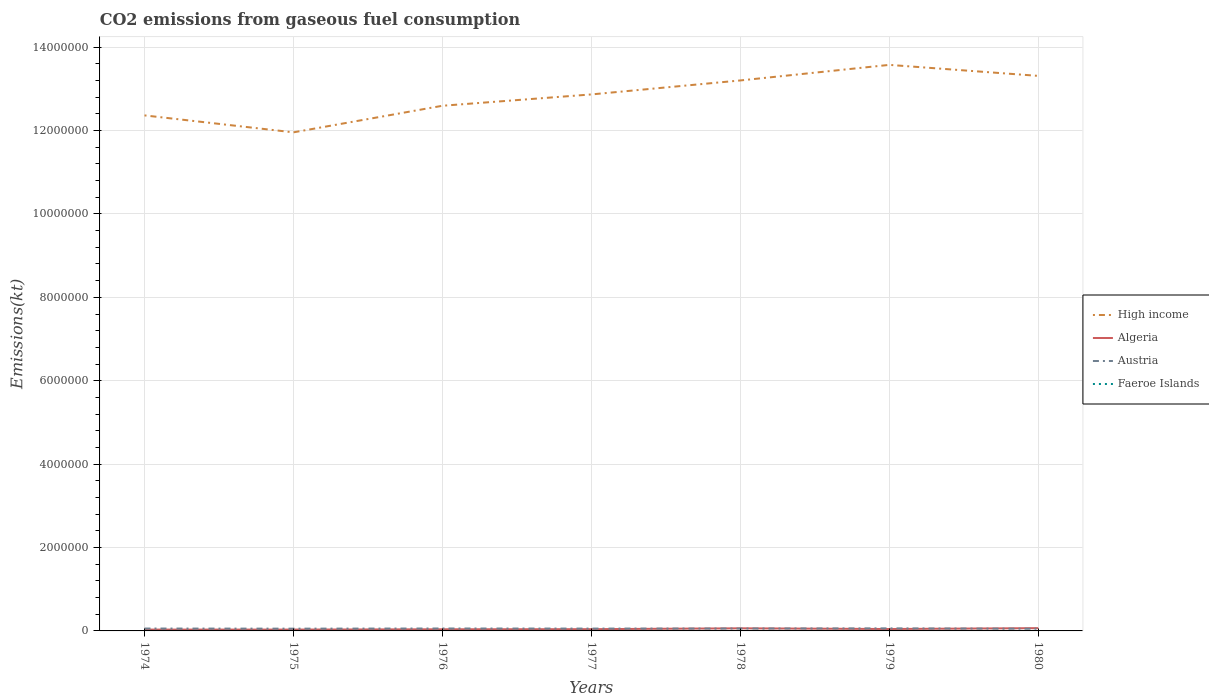Is the number of lines equal to the number of legend labels?
Give a very brief answer. Yes. Across all years, what is the maximum amount of CO2 emitted in Faeroe Islands?
Make the answer very short. 300.69. In which year was the amount of CO2 emitted in High income maximum?
Provide a short and direct response. 1975. What is the total amount of CO2 emitted in High income in the graph?
Keep it short and to the point. -3.73e+05. What is the difference between the highest and the second highest amount of CO2 emitted in High income?
Ensure brevity in your answer.  1.62e+06. Is the amount of CO2 emitted in Algeria strictly greater than the amount of CO2 emitted in Austria over the years?
Make the answer very short. No. What is the difference between two consecutive major ticks on the Y-axis?
Ensure brevity in your answer.  2.00e+06. Does the graph contain any zero values?
Make the answer very short. No. Does the graph contain grids?
Your answer should be very brief. Yes. How are the legend labels stacked?
Offer a very short reply. Vertical. What is the title of the graph?
Provide a short and direct response. CO2 emissions from gaseous fuel consumption. Does "Egypt, Arab Rep." appear as one of the legend labels in the graph?
Make the answer very short. No. What is the label or title of the Y-axis?
Your answer should be compact. Emissions(kt). What is the Emissions(kt) in High income in 1974?
Offer a very short reply. 1.24e+07. What is the Emissions(kt) in Algeria in 1974?
Offer a terse response. 3.19e+04. What is the Emissions(kt) in Austria in 1974?
Your answer should be very brief. 5.75e+04. What is the Emissions(kt) in Faeroe Islands in 1974?
Ensure brevity in your answer.  300.69. What is the Emissions(kt) of High income in 1975?
Offer a very short reply. 1.20e+07. What is the Emissions(kt) in Algeria in 1975?
Provide a succinct answer. 3.20e+04. What is the Emissions(kt) of Austria in 1975?
Provide a short and direct response. 5.44e+04. What is the Emissions(kt) in Faeroe Islands in 1975?
Keep it short and to the point. 348.37. What is the Emissions(kt) of High income in 1976?
Keep it short and to the point. 1.26e+07. What is the Emissions(kt) of Algeria in 1976?
Offer a very short reply. 3.92e+04. What is the Emissions(kt) in Austria in 1976?
Your answer should be very brief. 5.84e+04. What is the Emissions(kt) in Faeroe Islands in 1976?
Offer a terse response. 330.03. What is the Emissions(kt) of High income in 1977?
Offer a terse response. 1.29e+07. What is the Emissions(kt) of Algeria in 1977?
Keep it short and to the point. 4.19e+04. What is the Emissions(kt) of Austria in 1977?
Make the answer very short. 5.62e+04. What is the Emissions(kt) of Faeroe Islands in 1977?
Your answer should be compact. 407.04. What is the Emissions(kt) of High income in 1978?
Ensure brevity in your answer.  1.32e+07. What is the Emissions(kt) in Algeria in 1978?
Make the answer very short. 6.25e+04. What is the Emissions(kt) of Austria in 1978?
Provide a succinct answer. 5.75e+04. What is the Emissions(kt) in Faeroe Islands in 1978?
Offer a very short reply. 399.7. What is the Emissions(kt) of High income in 1979?
Provide a succinct answer. 1.36e+07. What is the Emissions(kt) in Algeria in 1979?
Offer a terse response. 4.56e+04. What is the Emissions(kt) in Austria in 1979?
Offer a very short reply. 6.16e+04. What is the Emissions(kt) of Faeroe Islands in 1979?
Make the answer very short. 480.38. What is the Emissions(kt) of High income in 1980?
Ensure brevity in your answer.  1.33e+07. What is the Emissions(kt) of Algeria in 1980?
Your response must be concise. 6.65e+04. What is the Emissions(kt) in Austria in 1980?
Offer a very short reply. 5.23e+04. What is the Emissions(kt) in Faeroe Islands in 1980?
Your answer should be very brief. 421.7. Across all years, what is the maximum Emissions(kt) in High income?
Ensure brevity in your answer.  1.36e+07. Across all years, what is the maximum Emissions(kt) of Algeria?
Provide a succinct answer. 6.65e+04. Across all years, what is the maximum Emissions(kt) in Austria?
Your answer should be compact. 6.16e+04. Across all years, what is the maximum Emissions(kt) in Faeroe Islands?
Your answer should be very brief. 480.38. Across all years, what is the minimum Emissions(kt) in High income?
Your response must be concise. 1.20e+07. Across all years, what is the minimum Emissions(kt) in Algeria?
Your answer should be compact. 3.19e+04. Across all years, what is the minimum Emissions(kt) of Austria?
Offer a very short reply. 5.23e+04. Across all years, what is the minimum Emissions(kt) in Faeroe Islands?
Provide a succinct answer. 300.69. What is the total Emissions(kt) in High income in the graph?
Offer a terse response. 8.99e+07. What is the total Emissions(kt) in Algeria in the graph?
Your answer should be compact. 3.20e+05. What is the total Emissions(kt) in Austria in the graph?
Make the answer very short. 3.98e+05. What is the total Emissions(kt) in Faeroe Islands in the graph?
Provide a short and direct response. 2687.91. What is the difference between the Emissions(kt) in High income in 1974 and that in 1975?
Ensure brevity in your answer.  4.07e+05. What is the difference between the Emissions(kt) in Algeria in 1974 and that in 1975?
Keep it short and to the point. -124.68. What is the difference between the Emissions(kt) of Austria in 1974 and that in 1975?
Ensure brevity in your answer.  3076.61. What is the difference between the Emissions(kt) in Faeroe Islands in 1974 and that in 1975?
Provide a short and direct response. -47.67. What is the difference between the Emissions(kt) of High income in 1974 and that in 1976?
Provide a succinct answer. -2.31e+05. What is the difference between the Emissions(kt) of Algeria in 1974 and that in 1976?
Your answer should be compact. -7264.33. What is the difference between the Emissions(kt) in Austria in 1974 and that in 1976?
Offer a terse response. -946.09. What is the difference between the Emissions(kt) of Faeroe Islands in 1974 and that in 1976?
Offer a very short reply. -29.34. What is the difference between the Emissions(kt) of High income in 1974 and that in 1977?
Ensure brevity in your answer.  -5.03e+05. What is the difference between the Emissions(kt) of Algeria in 1974 and that in 1977?
Offer a terse response. -9985.24. What is the difference between the Emissions(kt) of Austria in 1974 and that in 1977?
Provide a short and direct response. 1250.45. What is the difference between the Emissions(kt) in Faeroe Islands in 1974 and that in 1977?
Provide a short and direct response. -106.34. What is the difference between the Emissions(kt) in High income in 1974 and that in 1978?
Make the answer very short. -8.38e+05. What is the difference between the Emissions(kt) of Algeria in 1974 and that in 1978?
Provide a succinct answer. -3.06e+04. What is the difference between the Emissions(kt) in Austria in 1974 and that in 1978?
Offer a very short reply. -14.67. What is the difference between the Emissions(kt) in Faeroe Islands in 1974 and that in 1978?
Keep it short and to the point. -99.01. What is the difference between the Emissions(kt) of High income in 1974 and that in 1979?
Your answer should be very brief. -1.21e+06. What is the difference between the Emissions(kt) in Algeria in 1974 and that in 1979?
Offer a very short reply. -1.37e+04. What is the difference between the Emissions(kt) of Austria in 1974 and that in 1979?
Offer a terse response. -4125.38. What is the difference between the Emissions(kt) in Faeroe Islands in 1974 and that in 1979?
Your answer should be very brief. -179.68. What is the difference between the Emissions(kt) of High income in 1974 and that in 1980?
Your response must be concise. -9.48e+05. What is the difference between the Emissions(kt) of Algeria in 1974 and that in 1980?
Provide a short and direct response. -3.46e+04. What is the difference between the Emissions(kt) in Austria in 1974 and that in 1980?
Provide a short and direct response. 5163.14. What is the difference between the Emissions(kt) in Faeroe Islands in 1974 and that in 1980?
Keep it short and to the point. -121.01. What is the difference between the Emissions(kt) in High income in 1975 and that in 1976?
Your answer should be very brief. -6.37e+05. What is the difference between the Emissions(kt) of Algeria in 1975 and that in 1976?
Provide a succinct answer. -7139.65. What is the difference between the Emissions(kt) of Austria in 1975 and that in 1976?
Offer a terse response. -4022.7. What is the difference between the Emissions(kt) in Faeroe Islands in 1975 and that in 1976?
Provide a short and direct response. 18.34. What is the difference between the Emissions(kt) in High income in 1975 and that in 1977?
Your answer should be compact. -9.09e+05. What is the difference between the Emissions(kt) of Algeria in 1975 and that in 1977?
Ensure brevity in your answer.  -9860.56. What is the difference between the Emissions(kt) in Austria in 1975 and that in 1977?
Provide a succinct answer. -1826.17. What is the difference between the Emissions(kt) in Faeroe Islands in 1975 and that in 1977?
Your answer should be compact. -58.67. What is the difference between the Emissions(kt) of High income in 1975 and that in 1978?
Your answer should be very brief. -1.24e+06. What is the difference between the Emissions(kt) of Algeria in 1975 and that in 1978?
Your answer should be very brief. -3.05e+04. What is the difference between the Emissions(kt) of Austria in 1975 and that in 1978?
Your answer should be very brief. -3091.28. What is the difference between the Emissions(kt) of Faeroe Islands in 1975 and that in 1978?
Your response must be concise. -51.34. What is the difference between the Emissions(kt) of High income in 1975 and that in 1979?
Make the answer very short. -1.62e+06. What is the difference between the Emissions(kt) of Algeria in 1975 and that in 1979?
Offer a terse response. -1.36e+04. What is the difference between the Emissions(kt) of Austria in 1975 and that in 1979?
Offer a very short reply. -7201.99. What is the difference between the Emissions(kt) in Faeroe Islands in 1975 and that in 1979?
Offer a very short reply. -132.01. What is the difference between the Emissions(kt) in High income in 1975 and that in 1980?
Provide a short and direct response. -1.35e+06. What is the difference between the Emissions(kt) in Algeria in 1975 and that in 1980?
Provide a succinct answer. -3.45e+04. What is the difference between the Emissions(kt) in Austria in 1975 and that in 1980?
Offer a very short reply. 2086.52. What is the difference between the Emissions(kt) of Faeroe Islands in 1975 and that in 1980?
Provide a succinct answer. -73.34. What is the difference between the Emissions(kt) of High income in 1976 and that in 1977?
Make the answer very short. -2.72e+05. What is the difference between the Emissions(kt) in Algeria in 1976 and that in 1977?
Offer a very short reply. -2720.91. What is the difference between the Emissions(kt) in Austria in 1976 and that in 1977?
Keep it short and to the point. 2196.53. What is the difference between the Emissions(kt) of Faeroe Islands in 1976 and that in 1977?
Keep it short and to the point. -77.01. What is the difference between the Emissions(kt) in High income in 1976 and that in 1978?
Offer a terse response. -6.07e+05. What is the difference between the Emissions(kt) in Algeria in 1976 and that in 1978?
Your answer should be very brief. -2.34e+04. What is the difference between the Emissions(kt) in Austria in 1976 and that in 1978?
Your answer should be compact. 931.42. What is the difference between the Emissions(kt) of Faeroe Islands in 1976 and that in 1978?
Make the answer very short. -69.67. What is the difference between the Emissions(kt) of High income in 1976 and that in 1979?
Provide a succinct answer. -9.81e+05. What is the difference between the Emissions(kt) in Algeria in 1976 and that in 1979?
Provide a succinct answer. -6450.25. What is the difference between the Emissions(kt) of Austria in 1976 and that in 1979?
Your response must be concise. -3179.29. What is the difference between the Emissions(kt) in Faeroe Islands in 1976 and that in 1979?
Provide a short and direct response. -150.35. What is the difference between the Emissions(kt) of High income in 1976 and that in 1980?
Ensure brevity in your answer.  -7.17e+05. What is the difference between the Emissions(kt) of Algeria in 1976 and that in 1980?
Offer a terse response. -2.73e+04. What is the difference between the Emissions(kt) in Austria in 1976 and that in 1980?
Make the answer very short. 6109.22. What is the difference between the Emissions(kt) in Faeroe Islands in 1976 and that in 1980?
Offer a terse response. -91.67. What is the difference between the Emissions(kt) of High income in 1977 and that in 1978?
Give a very brief answer. -3.35e+05. What is the difference between the Emissions(kt) of Algeria in 1977 and that in 1978?
Provide a succinct answer. -2.06e+04. What is the difference between the Emissions(kt) of Austria in 1977 and that in 1978?
Ensure brevity in your answer.  -1265.12. What is the difference between the Emissions(kt) of Faeroe Islands in 1977 and that in 1978?
Make the answer very short. 7.33. What is the difference between the Emissions(kt) of High income in 1977 and that in 1979?
Provide a short and direct response. -7.09e+05. What is the difference between the Emissions(kt) in Algeria in 1977 and that in 1979?
Make the answer very short. -3729.34. What is the difference between the Emissions(kt) in Austria in 1977 and that in 1979?
Ensure brevity in your answer.  -5375.82. What is the difference between the Emissions(kt) of Faeroe Islands in 1977 and that in 1979?
Your answer should be compact. -73.34. What is the difference between the Emissions(kt) of High income in 1977 and that in 1980?
Ensure brevity in your answer.  -4.45e+05. What is the difference between the Emissions(kt) of Algeria in 1977 and that in 1980?
Ensure brevity in your answer.  -2.46e+04. What is the difference between the Emissions(kt) in Austria in 1977 and that in 1980?
Your response must be concise. 3912.69. What is the difference between the Emissions(kt) of Faeroe Islands in 1977 and that in 1980?
Keep it short and to the point. -14.67. What is the difference between the Emissions(kt) in High income in 1978 and that in 1979?
Give a very brief answer. -3.73e+05. What is the difference between the Emissions(kt) in Algeria in 1978 and that in 1979?
Offer a terse response. 1.69e+04. What is the difference between the Emissions(kt) of Austria in 1978 and that in 1979?
Give a very brief answer. -4110.71. What is the difference between the Emissions(kt) in Faeroe Islands in 1978 and that in 1979?
Your answer should be compact. -80.67. What is the difference between the Emissions(kt) of High income in 1978 and that in 1980?
Provide a succinct answer. -1.10e+05. What is the difference between the Emissions(kt) of Algeria in 1978 and that in 1980?
Make the answer very short. -3989.7. What is the difference between the Emissions(kt) in Austria in 1978 and that in 1980?
Provide a succinct answer. 5177.8. What is the difference between the Emissions(kt) in Faeroe Islands in 1978 and that in 1980?
Your answer should be compact. -22. What is the difference between the Emissions(kt) in High income in 1979 and that in 1980?
Provide a succinct answer. 2.64e+05. What is the difference between the Emissions(kt) of Algeria in 1979 and that in 1980?
Give a very brief answer. -2.09e+04. What is the difference between the Emissions(kt) in Austria in 1979 and that in 1980?
Your answer should be compact. 9288.51. What is the difference between the Emissions(kt) in Faeroe Islands in 1979 and that in 1980?
Your answer should be very brief. 58.67. What is the difference between the Emissions(kt) in High income in 1974 and the Emissions(kt) in Algeria in 1975?
Keep it short and to the point. 1.23e+07. What is the difference between the Emissions(kt) in High income in 1974 and the Emissions(kt) in Austria in 1975?
Your answer should be compact. 1.23e+07. What is the difference between the Emissions(kt) in High income in 1974 and the Emissions(kt) in Faeroe Islands in 1975?
Your response must be concise. 1.24e+07. What is the difference between the Emissions(kt) of Algeria in 1974 and the Emissions(kt) of Austria in 1975?
Your response must be concise. -2.25e+04. What is the difference between the Emissions(kt) in Algeria in 1974 and the Emissions(kt) in Faeroe Islands in 1975?
Provide a short and direct response. 3.16e+04. What is the difference between the Emissions(kt) of Austria in 1974 and the Emissions(kt) of Faeroe Islands in 1975?
Your response must be concise. 5.71e+04. What is the difference between the Emissions(kt) in High income in 1974 and the Emissions(kt) in Algeria in 1976?
Give a very brief answer. 1.23e+07. What is the difference between the Emissions(kt) in High income in 1974 and the Emissions(kt) in Austria in 1976?
Offer a very short reply. 1.23e+07. What is the difference between the Emissions(kt) of High income in 1974 and the Emissions(kt) of Faeroe Islands in 1976?
Make the answer very short. 1.24e+07. What is the difference between the Emissions(kt) in Algeria in 1974 and the Emissions(kt) in Austria in 1976?
Give a very brief answer. -2.65e+04. What is the difference between the Emissions(kt) of Algeria in 1974 and the Emissions(kt) of Faeroe Islands in 1976?
Your response must be concise. 3.16e+04. What is the difference between the Emissions(kt) of Austria in 1974 and the Emissions(kt) of Faeroe Islands in 1976?
Keep it short and to the point. 5.71e+04. What is the difference between the Emissions(kt) of High income in 1974 and the Emissions(kt) of Algeria in 1977?
Ensure brevity in your answer.  1.23e+07. What is the difference between the Emissions(kt) in High income in 1974 and the Emissions(kt) in Austria in 1977?
Offer a terse response. 1.23e+07. What is the difference between the Emissions(kt) in High income in 1974 and the Emissions(kt) in Faeroe Islands in 1977?
Make the answer very short. 1.24e+07. What is the difference between the Emissions(kt) in Algeria in 1974 and the Emissions(kt) in Austria in 1977?
Offer a terse response. -2.43e+04. What is the difference between the Emissions(kt) in Algeria in 1974 and the Emissions(kt) in Faeroe Islands in 1977?
Your answer should be very brief. 3.15e+04. What is the difference between the Emissions(kt) in Austria in 1974 and the Emissions(kt) in Faeroe Islands in 1977?
Your response must be concise. 5.71e+04. What is the difference between the Emissions(kt) in High income in 1974 and the Emissions(kt) in Algeria in 1978?
Give a very brief answer. 1.23e+07. What is the difference between the Emissions(kt) of High income in 1974 and the Emissions(kt) of Austria in 1978?
Your answer should be very brief. 1.23e+07. What is the difference between the Emissions(kt) in High income in 1974 and the Emissions(kt) in Faeroe Islands in 1978?
Give a very brief answer. 1.24e+07. What is the difference between the Emissions(kt) in Algeria in 1974 and the Emissions(kt) in Austria in 1978?
Ensure brevity in your answer.  -2.56e+04. What is the difference between the Emissions(kt) of Algeria in 1974 and the Emissions(kt) of Faeroe Islands in 1978?
Your answer should be very brief. 3.15e+04. What is the difference between the Emissions(kt) in Austria in 1974 and the Emissions(kt) in Faeroe Islands in 1978?
Provide a short and direct response. 5.71e+04. What is the difference between the Emissions(kt) of High income in 1974 and the Emissions(kt) of Algeria in 1979?
Give a very brief answer. 1.23e+07. What is the difference between the Emissions(kt) in High income in 1974 and the Emissions(kt) in Austria in 1979?
Your answer should be very brief. 1.23e+07. What is the difference between the Emissions(kt) in High income in 1974 and the Emissions(kt) in Faeroe Islands in 1979?
Your answer should be very brief. 1.24e+07. What is the difference between the Emissions(kt) in Algeria in 1974 and the Emissions(kt) in Austria in 1979?
Make the answer very short. -2.97e+04. What is the difference between the Emissions(kt) in Algeria in 1974 and the Emissions(kt) in Faeroe Islands in 1979?
Offer a very short reply. 3.14e+04. What is the difference between the Emissions(kt) of Austria in 1974 and the Emissions(kt) of Faeroe Islands in 1979?
Give a very brief answer. 5.70e+04. What is the difference between the Emissions(kt) of High income in 1974 and the Emissions(kt) of Algeria in 1980?
Make the answer very short. 1.23e+07. What is the difference between the Emissions(kt) in High income in 1974 and the Emissions(kt) in Austria in 1980?
Offer a terse response. 1.23e+07. What is the difference between the Emissions(kt) in High income in 1974 and the Emissions(kt) in Faeroe Islands in 1980?
Your response must be concise. 1.24e+07. What is the difference between the Emissions(kt) in Algeria in 1974 and the Emissions(kt) in Austria in 1980?
Your answer should be very brief. -2.04e+04. What is the difference between the Emissions(kt) of Algeria in 1974 and the Emissions(kt) of Faeroe Islands in 1980?
Ensure brevity in your answer.  3.15e+04. What is the difference between the Emissions(kt) in Austria in 1974 and the Emissions(kt) in Faeroe Islands in 1980?
Provide a succinct answer. 5.70e+04. What is the difference between the Emissions(kt) in High income in 1975 and the Emissions(kt) in Algeria in 1976?
Offer a very short reply. 1.19e+07. What is the difference between the Emissions(kt) of High income in 1975 and the Emissions(kt) of Austria in 1976?
Keep it short and to the point. 1.19e+07. What is the difference between the Emissions(kt) in High income in 1975 and the Emissions(kt) in Faeroe Islands in 1976?
Offer a terse response. 1.20e+07. What is the difference between the Emissions(kt) in Algeria in 1975 and the Emissions(kt) in Austria in 1976?
Provide a succinct answer. -2.64e+04. What is the difference between the Emissions(kt) of Algeria in 1975 and the Emissions(kt) of Faeroe Islands in 1976?
Your answer should be compact. 3.17e+04. What is the difference between the Emissions(kt) of Austria in 1975 and the Emissions(kt) of Faeroe Islands in 1976?
Your answer should be compact. 5.41e+04. What is the difference between the Emissions(kt) of High income in 1975 and the Emissions(kt) of Algeria in 1977?
Your answer should be compact. 1.19e+07. What is the difference between the Emissions(kt) in High income in 1975 and the Emissions(kt) in Austria in 1977?
Provide a short and direct response. 1.19e+07. What is the difference between the Emissions(kt) of High income in 1975 and the Emissions(kt) of Faeroe Islands in 1977?
Make the answer very short. 1.20e+07. What is the difference between the Emissions(kt) in Algeria in 1975 and the Emissions(kt) in Austria in 1977?
Your answer should be compact. -2.42e+04. What is the difference between the Emissions(kt) in Algeria in 1975 and the Emissions(kt) in Faeroe Islands in 1977?
Keep it short and to the point. 3.16e+04. What is the difference between the Emissions(kt) of Austria in 1975 and the Emissions(kt) of Faeroe Islands in 1977?
Your answer should be compact. 5.40e+04. What is the difference between the Emissions(kt) in High income in 1975 and the Emissions(kt) in Algeria in 1978?
Make the answer very short. 1.19e+07. What is the difference between the Emissions(kt) of High income in 1975 and the Emissions(kt) of Austria in 1978?
Ensure brevity in your answer.  1.19e+07. What is the difference between the Emissions(kt) of High income in 1975 and the Emissions(kt) of Faeroe Islands in 1978?
Provide a succinct answer. 1.20e+07. What is the difference between the Emissions(kt) in Algeria in 1975 and the Emissions(kt) in Austria in 1978?
Keep it short and to the point. -2.55e+04. What is the difference between the Emissions(kt) of Algeria in 1975 and the Emissions(kt) of Faeroe Islands in 1978?
Provide a short and direct response. 3.16e+04. What is the difference between the Emissions(kt) of Austria in 1975 and the Emissions(kt) of Faeroe Islands in 1978?
Offer a very short reply. 5.40e+04. What is the difference between the Emissions(kt) in High income in 1975 and the Emissions(kt) in Algeria in 1979?
Offer a very short reply. 1.19e+07. What is the difference between the Emissions(kt) in High income in 1975 and the Emissions(kt) in Austria in 1979?
Your answer should be compact. 1.19e+07. What is the difference between the Emissions(kt) in High income in 1975 and the Emissions(kt) in Faeroe Islands in 1979?
Provide a short and direct response. 1.20e+07. What is the difference between the Emissions(kt) of Algeria in 1975 and the Emissions(kt) of Austria in 1979?
Your answer should be compact. -2.96e+04. What is the difference between the Emissions(kt) in Algeria in 1975 and the Emissions(kt) in Faeroe Islands in 1979?
Your answer should be very brief. 3.16e+04. What is the difference between the Emissions(kt) in Austria in 1975 and the Emissions(kt) in Faeroe Islands in 1979?
Keep it short and to the point. 5.39e+04. What is the difference between the Emissions(kt) in High income in 1975 and the Emissions(kt) in Algeria in 1980?
Give a very brief answer. 1.19e+07. What is the difference between the Emissions(kt) in High income in 1975 and the Emissions(kt) in Austria in 1980?
Your response must be concise. 1.19e+07. What is the difference between the Emissions(kt) in High income in 1975 and the Emissions(kt) in Faeroe Islands in 1980?
Your answer should be compact. 1.20e+07. What is the difference between the Emissions(kt) of Algeria in 1975 and the Emissions(kt) of Austria in 1980?
Keep it short and to the point. -2.03e+04. What is the difference between the Emissions(kt) of Algeria in 1975 and the Emissions(kt) of Faeroe Islands in 1980?
Ensure brevity in your answer.  3.16e+04. What is the difference between the Emissions(kt) of Austria in 1975 and the Emissions(kt) of Faeroe Islands in 1980?
Provide a succinct answer. 5.40e+04. What is the difference between the Emissions(kt) in High income in 1976 and the Emissions(kt) in Algeria in 1977?
Give a very brief answer. 1.26e+07. What is the difference between the Emissions(kt) in High income in 1976 and the Emissions(kt) in Austria in 1977?
Provide a short and direct response. 1.25e+07. What is the difference between the Emissions(kt) in High income in 1976 and the Emissions(kt) in Faeroe Islands in 1977?
Ensure brevity in your answer.  1.26e+07. What is the difference between the Emissions(kt) of Algeria in 1976 and the Emissions(kt) of Austria in 1977?
Your answer should be very brief. -1.70e+04. What is the difference between the Emissions(kt) in Algeria in 1976 and the Emissions(kt) in Faeroe Islands in 1977?
Give a very brief answer. 3.88e+04. What is the difference between the Emissions(kt) in Austria in 1976 and the Emissions(kt) in Faeroe Islands in 1977?
Provide a short and direct response. 5.80e+04. What is the difference between the Emissions(kt) in High income in 1976 and the Emissions(kt) in Algeria in 1978?
Provide a succinct answer. 1.25e+07. What is the difference between the Emissions(kt) of High income in 1976 and the Emissions(kt) of Austria in 1978?
Offer a terse response. 1.25e+07. What is the difference between the Emissions(kt) of High income in 1976 and the Emissions(kt) of Faeroe Islands in 1978?
Provide a short and direct response. 1.26e+07. What is the difference between the Emissions(kt) in Algeria in 1976 and the Emissions(kt) in Austria in 1978?
Your answer should be compact. -1.83e+04. What is the difference between the Emissions(kt) of Algeria in 1976 and the Emissions(kt) of Faeroe Islands in 1978?
Provide a succinct answer. 3.88e+04. What is the difference between the Emissions(kt) of Austria in 1976 and the Emissions(kt) of Faeroe Islands in 1978?
Offer a very short reply. 5.80e+04. What is the difference between the Emissions(kt) of High income in 1976 and the Emissions(kt) of Algeria in 1979?
Offer a very short reply. 1.25e+07. What is the difference between the Emissions(kt) of High income in 1976 and the Emissions(kt) of Austria in 1979?
Keep it short and to the point. 1.25e+07. What is the difference between the Emissions(kt) in High income in 1976 and the Emissions(kt) in Faeroe Islands in 1979?
Offer a terse response. 1.26e+07. What is the difference between the Emissions(kt) in Algeria in 1976 and the Emissions(kt) in Austria in 1979?
Make the answer very short. -2.24e+04. What is the difference between the Emissions(kt) of Algeria in 1976 and the Emissions(kt) of Faeroe Islands in 1979?
Offer a very short reply. 3.87e+04. What is the difference between the Emissions(kt) of Austria in 1976 and the Emissions(kt) of Faeroe Islands in 1979?
Your answer should be compact. 5.79e+04. What is the difference between the Emissions(kt) of High income in 1976 and the Emissions(kt) of Algeria in 1980?
Offer a very short reply. 1.25e+07. What is the difference between the Emissions(kt) of High income in 1976 and the Emissions(kt) of Austria in 1980?
Your answer should be very brief. 1.25e+07. What is the difference between the Emissions(kt) of High income in 1976 and the Emissions(kt) of Faeroe Islands in 1980?
Your answer should be very brief. 1.26e+07. What is the difference between the Emissions(kt) of Algeria in 1976 and the Emissions(kt) of Austria in 1980?
Offer a terse response. -1.31e+04. What is the difference between the Emissions(kt) of Algeria in 1976 and the Emissions(kt) of Faeroe Islands in 1980?
Offer a terse response. 3.87e+04. What is the difference between the Emissions(kt) of Austria in 1976 and the Emissions(kt) of Faeroe Islands in 1980?
Provide a succinct answer. 5.80e+04. What is the difference between the Emissions(kt) in High income in 1977 and the Emissions(kt) in Algeria in 1978?
Provide a short and direct response. 1.28e+07. What is the difference between the Emissions(kt) in High income in 1977 and the Emissions(kt) in Austria in 1978?
Your response must be concise. 1.28e+07. What is the difference between the Emissions(kt) of High income in 1977 and the Emissions(kt) of Faeroe Islands in 1978?
Provide a short and direct response. 1.29e+07. What is the difference between the Emissions(kt) in Algeria in 1977 and the Emissions(kt) in Austria in 1978?
Give a very brief answer. -1.56e+04. What is the difference between the Emissions(kt) of Algeria in 1977 and the Emissions(kt) of Faeroe Islands in 1978?
Your answer should be very brief. 4.15e+04. What is the difference between the Emissions(kt) in Austria in 1977 and the Emissions(kt) in Faeroe Islands in 1978?
Your answer should be very brief. 5.58e+04. What is the difference between the Emissions(kt) of High income in 1977 and the Emissions(kt) of Algeria in 1979?
Keep it short and to the point. 1.28e+07. What is the difference between the Emissions(kt) of High income in 1977 and the Emissions(kt) of Austria in 1979?
Provide a short and direct response. 1.28e+07. What is the difference between the Emissions(kt) of High income in 1977 and the Emissions(kt) of Faeroe Islands in 1979?
Your answer should be very brief. 1.29e+07. What is the difference between the Emissions(kt) in Algeria in 1977 and the Emissions(kt) in Austria in 1979?
Ensure brevity in your answer.  -1.97e+04. What is the difference between the Emissions(kt) of Algeria in 1977 and the Emissions(kt) of Faeroe Islands in 1979?
Your response must be concise. 4.14e+04. What is the difference between the Emissions(kt) of Austria in 1977 and the Emissions(kt) of Faeroe Islands in 1979?
Make the answer very short. 5.57e+04. What is the difference between the Emissions(kt) of High income in 1977 and the Emissions(kt) of Algeria in 1980?
Offer a very short reply. 1.28e+07. What is the difference between the Emissions(kt) of High income in 1977 and the Emissions(kt) of Austria in 1980?
Your response must be concise. 1.28e+07. What is the difference between the Emissions(kt) of High income in 1977 and the Emissions(kt) of Faeroe Islands in 1980?
Offer a terse response. 1.29e+07. What is the difference between the Emissions(kt) of Algeria in 1977 and the Emissions(kt) of Austria in 1980?
Offer a very short reply. -1.04e+04. What is the difference between the Emissions(kt) in Algeria in 1977 and the Emissions(kt) in Faeroe Islands in 1980?
Keep it short and to the point. 4.15e+04. What is the difference between the Emissions(kt) in Austria in 1977 and the Emissions(kt) in Faeroe Islands in 1980?
Provide a short and direct response. 5.58e+04. What is the difference between the Emissions(kt) in High income in 1978 and the Emissions(kt) in Algeria in 1979?
Offer a terse response. 1.32e+07. What is the difference between the Emissions(kt) in High income in 1978 and the Emissions(kt) in Austria in 1979?
Your answer should be compact. 1.31e+07. What is the difference between the Emissions(kt) of High income in 1978 and the Emissions(kt) of Faeroe Islands in 1979?
Offer a terse response. 1.32e+07. What is the difference between the Emissions(kt) of Algeria in 1978 and the Emissions(kt) of Austria in 1979?
Ensure brevity in your answer.  935.09. What is the difference between the Emissions(kt) in Algeria in 1978 and the Emissions(kt) in Faeroe Islands in 1979?
Your answer should be very brief. 6.20e+04. What is the difference between the Emissions(kt) in Austria in 1978 and the Emissions(kt) in Faeroe Islands in 1979?
Give a very brief answer. 5.70e+04. What is the difference between the Emissions(kt) in High income in 1978 and the Emissions(kt) in Algeria in 1980?
Your response must be concise. 1.31e+07. What is the difference between the Emissions(kt) in High income in 1978 and the Emissions(kt) in Austria in 1980?
Provide a succinct answer. 1.31e+07. What is the difference between the Emissions(kt) in High income in 1978 and the Emissions(kt) in Faeroe Islands in 1980?
Provide a succinct answer. 1.32e+07. What is the difference between the Emissions(kt) of Algeria in 1978 and the Emissions(kt) of Austria in 1980?
Keep it short and to the point. 1.02e+04. What is the difference between the Emissions(kt) in Algeria in 1978 and the Emissions(kt) in Faeroe Islands in 1980?
Your answer should be compact. 6.21e+04. What is the difference between the Emissions(kt) in Austria in 1978 and the Emissions(kt) in Faeroe Islands in 1980?
Offer a terse response. 5.71e+04. What is the difference between the Emissions(kt) in High income in 1979 and the Emissions(kt) in Algeria in 1980?
Offer a very short reply. 1.35e+07. What is the difference between the Emissions(kt) of High income in 1979 and the Emissions(kt) of Austria in 1980?
Provide a short and direct response. 1.35e+07. What is the difference between the Emissions(kt) of High income in 1979 and the Emissions(kt) of Faeroe Islands in 1980?
Your response must be concise. 1.36e+07. What is the difference between the Emissions(kt) of Algeria in 1979 and the Emissions(kt) of Austria in 1980?
Provide a succinct answer. -6684.94. What is the difference between the Emissions(kt) of Algeria in 1979 and the Emissions(kt) of Faeroe Islands in 1980?
Offer a very short reply. 4.52e+04. What is the difference between the Emissions(kt) of Austria in 1979 and the Emissions(kt) of Faeroe Islands in 1980?
Keep it short and to the point. 6.12e+04. What is the average Emissions(kt) in High income per year?
Offer a terse response. 1.28e+07. What is the average Emissions(kt) in Algeria per year?
Your response must be concise. 4.57e+04. What is the average Emissions(kt) of Austria per year?
Your response must be concise. 5.68e+04. What is the average Emissions(kt) of Faeroe Islands per year?
Offer a terse response. 383.99. In the year 1974, what is the difference between the Emissions(kt) of High income and Emissions(kt) of Algeria?
Offer a very short reply. 1.23e+07. In the year 1974, what is the difference between the Emissions(kt) in High income and Emissions(kt) in Austria?
Provide a short and direct response. 1.23e+07. In the year 1974, what is the difference between the Emissions(kt) of High income and Emissions(kt) of Faeroe Islands?
Make the answer very short. 1.24e+07. In the year 1974, what is the difference between the Emissions(kt) in Algeria and Emissions(kt) in Austria?
Your answer should be very brief. -2.56e+04. In the year 1974, what is the difference between the Emissions(kt) of Algeria and Emissions(kt) of Faeroe Islands?
Provide a short and direct response. 3.16e+04. In the year 1974, what is the difference between the Emissions(kt) in Austria and Emissions(kt) in Faeroe Islands?
Provide a short and direct response. 5.72e+04. In the year 1975, what is the difference between the Emissions(kt) of High income and Emissions(kt) of Algeria?
Offer a terse response. 1.19e+07. In the year 1975, what is the difference between the Emissions(kt) of High income and Emissions(kt) of Austria?
Offer a terse response. 1.19e+07. In the year 1975, what is the difference between the Emissions(kt) in High income and Emissions(kt) in Faeroe Islands?
Provide a succinct answer. 1.20e+07. In the year 1975, what is the difference between the Emissions(kt) in Algeria and Emissions(kt) in Austria?
Provide a succinct answer. -2.24e+04. In the year 1975, what is the difference between the Emissions(kt) in Algeria and Emissions(kt) in Faeroe Islands?
Give a very brief answer. 3.17e+04. In the year 1975, what is the difference between the Emissions(kt) in Austria and Emissions(kt) in Faeroe Islands?
Offer a terse response. 5.40e+04. In the year 1976, what is the difference between the Emissions(kt) in High income and Emissions(kt) in Algeria?
Your response must be concise. 1.26e+07. In the year 1976, what is the difference between the Emissions(kt) in High income and Emissions(kt) in Austria?
Provide a succinct answer. 1.25e+07. In the year 1976, what is the difference between the Emissions(kt) in High income and Emissions(kt) in Faeroe Islands?
Provide a succinct answer. 1.26e+07. In the year 1976, what is the difference between the Emissions(kt) in Algeria and Emissions(kt) in Austria?
Keep it short and to the point. -1.92e+04. In the year 1976, what is the difference between the Emissions(kt) in Algeria and Emissions(kt) in Faeroe Islands?
Provide a succinct answer. 3.88e+04. In the year 1976, what is the difference between the Emissions(kt) of Austria and Emissions(kt) of Faeroe Islands?
Offer a terse response. 5.81e+04. In the year 1977, what is the difference between the Emissions(kt) of High income and Emissions(kt) of Algeria?
Provide a short and direct response. 1.28e+07. In the year 1977, what is the difference between the Emissions(kt) of High income and Emissions(kt) of Austria?
Offer a very short reply. 1.28e+07. In the year 1977, what is the difference between the Emissions(kt) of High income and Emissions(kt) of Faeroe Islands?
Provide a short and direct response. 1.29e+07. In the year 1977, what is the difference between the Emissions(kt) of Algeria and Emissions(kt) of Austria?
Offer a very short reply. -1.43e+04. In the year 1977, what is the difference between the Emissions(kt) of Algeria and Emissions(kt) of Faeroe Islands?
Give a very brief answer. 4.15e+04. In the year 1977, what is the difference between the Emissions(kt) in Austria and Emissions(kt) in Faeroe Islands?
Your answer should be compact. 5.58e+04. In the year 1978, what is the difference between the Emissions(kt) in High income and Emissions(kt) in Algeria?
Your response must be concise. 1.31e+07. In the year 1978, what is the difference between the Emissions(kt) of High income and Emissions(kt) of Austria?
Give a very brief answer. 1.31e+07. In the year 1978, what is the difference between the Emissions(kt) in High income and Emissions(kt) in Faeroe Islands?
Keep it short and to the point. 1.32e+07. In the year 1978, what is the difference between the Emissions(kt) in Algeria and Emissions(kt) in Austria?
Your answer should be compact. 5045.79. In the year 1978, what is the difference between the Emissions(kt) of Algeria and Emissions(kt) of Faeroe Islands?
Keep it short and to the point. 6.21e+04. In the year 1978, what is the difference between the Emissions(kt) of Austria and Emissions(kt) of Faeroe Islands?
Ensure brevity in your answer.  5.71e+04. In the year 1979, what is the difference between the Emissions(kt) in High income and Emissions(kt) in Algeria?
Give a very brief answer. 1.35e+07. In the year 1979, what is the difference between the Emissions(kt) of High income and Emissions(kt) of Austria?
Offer a terse response. 1.35e+07. In the year 1979, what is the difference between the Emissions(kt) in High income and Emissions(kt) in Faeroe Islands?
Your answer should be compact. 1.36e+07. In the year 1979, what is the difference between the Emissions(kt) of Algeria and Emissions(kt) of Austria?
Provide a succinct answer. -1.60e+04. In the year 1979, what is the difference between the Emissions(kt) in Algeria and Emissions(kt) in Faeroe Islands?
Your answer should be very brief. 4.51e+04. In the year 1979, what is the difference between the Emissions(kt) in Austria and Emissions(kt) in Faeroe Islands?
Provide a succinct answer. 6.11e+04. In the year 1980, what is the difference between the Emissions(kt) of High income and Emissions(kt) of Algeria?
Keep it short and to the point. 1.32e+07. In the year 1980, what is the difference between the Emissions(kt) of High income and Emissions(kt) of Austria?
Your answer should be very brief. 1.33e+07. In the year 1980, what is the difference between the Emissions(kt) in High income and Emissions(kt) in Faeroe Islands?
Keep it short and to the point. 1.33e+07. In the year 1980, what is the difference between the Emissions(kt) of Algeria and Emissions(kt) of Austria?
Keep it short and to the point. 1.42e+04. In the year 1980, what is the difference between the Emissions(kt) in Algeria and Emissions(kt) in Faeroe Islands?
Provide a short and direct response. 6.61e+04. In the year 1980, what is the difference between the Emissions(kt) of Austria and Emissions(kt) of Faeroe Islands?
Your answer should be compact. 5.19e+04. What is the ratio of the Emissions(kt) of High income in 1974 to that in 1975?
Give a very brief answer. 1.03. What is the ratio of the Emissions(kt) in Algeria in 1974 to that in 1975?
Your answer should be compact. 1. What is the ratio of the Emissions(kt) in Austria in 1974 to that in 1975?
Provide a short and direct response. 1.06. What is the ratio of the Emissions(kt) in Faeroe Islands in 1974 to that in 1975?
Offer a terse response. 0.86. What is the ratio of the Emissions(kt) of High income in 1974 to that in 1976?
Your answer should be compact. 0.98. What is the ratio of the Emissions(kt) in Algeria in 1974 to that in 1976?
Keep it short and to the point. 0.81. What is the ratio of the Emissions(kt) in Austria in 1974 to that in 1976?
Offer a very short reply. 0.98. What is the ratio of the Emissions(kt) of Faeroe Islands in 1974 to that in 1976?
Give a very brief answer. 0.91. What is the ratio of the Emissions(kt) in High income in 1974 to that in 1977?
Offer a very short reply. 0.96. What is the ratio of the Emissions(kt) of Algeria in 1974 to that in 1977?
Provide a succinct answer. 0.76. What is the ratio of the Emissions(kt) of Austria in 1974 to that in 1977?
Offer a very short reply. 1.02. What is the ratio of the Emissions(kt) of Faeroe Islands in 1974 to that in 1977?
Keep it short and to the point. 0.74. What is the ratio of the Emissions(kt) of High income in 1974 to that in 1978?
Offer a very short reply. 0.94. What is the ratio of the Emissions(kt) of Algeria in 1974 to that in 1978?
Your answer should be compact. 0.51. What is the ratio of the Emissions(kt) in Faeroe Islands in 1974 to that in 1978?
Make the answer very short. 0.75. What is the ratio of the Emissions(kt) in High income in 1974 to that in 1979?
Your response must be concise. 0.91. What is the ratio of the Emissions(kt) of Algeria in 1974 to that in 1979?
Keep it short and to the point. 0.7. What is the ratio of the Emissions(kt) of Austria in 1974 to that in 1979?
Give a very brief answer. 0.93. What is the ratio of the Emissions(kt) in Faeroe Islands in 1974 to that in 1979?
Give a very brief answer. 0.63. What is the ratio of the Emissions(kt) of High income in 1974 to that in 1980?
Provide a succinct answer. 0.93. What is the ratio of the Emissions(kt) of Algeria in 1974 to that in 1980?
Make the answer very short. 0.48. What is the ratio of the Emissions(kt) in Austria in 1974 to that in 1980?
Offer a terse response. 1.1. What is the ratio of the Emissions(kt) of Faeroe Islands in 1974 to that in 1980?
Provide a succinct answer. 0.71. What is the ratio of the Emissions(kt) of High income in 1975 to that in 1976?
Your answer should be compact. 0.95. What is the ratio of the Emissions(kt) in Algeria in 1975 to that in 1976?
Offer a terse response. 0.82. What is the ratio of the Emissions(kt) in Austria in 1975 to that in 1976?
Give a very brief answer. 0.93. What is the ratio of the Emissions(kt) in Faeroe Islands in 1975 to that in 1976?
Offer a very short reply. 1.06. What is the ratio of the Emissions(kt) of High income in 1975 to that in 1977?
Your answer should be very brief. 0.93. What is the ratio of the Emissions(kt) of Algeria in 1975 to that in 1977?
Offer a very short reply. 0.76. What is the ratio of the Emissions(kt) of Austria in 1975 to that in 1977?
Provide a short and direct response. 0.97. What is the ratio of the Emissions(kt) of Faeroe Islands in 1975 to that in 1977?
Your answer should be very brief. 0.86. What is the ratio of the Emissions(kt) of High income in 1975 to that in 1978?
Your response must be concise. 0.91. What is the ratio of the Emissions(kt) in Algeria in 1975 to that in 1978?
Offer a terse response. 0.51. What is the ratio of the Emissions(kt) in Austria in 1975 to that in 1978?
Your answer should be compact. 0.95. What is the ratio of the Emissions(kt) in Faeroe Islands in 1975 to that in 1978?
Provide a short and direct response. 0.87. What is the ratio of the Emissions(kt) in High income in 1975 to that in 1979?
Provide a succinct answer. 0.88. What is the ratio of the Emissions(kt) of Algeria in 1975 to that in 1979?
Keep it short and to the point. 0.7. What is the ratio of the Emissions(kt) of Austria in 1975 to that in 1979?
Give a very brief answer. 0.88. What is the ratio of the Emissions(kt) in Faeroe Islands in 1975 to that in 1979?
Your answer should be very brief. 0.73. What is the ratio of the Emissions(kt) in High income in 1975 to that in 1980?
Offer a very short reply. 0.9. What is the ratio of the Emissions(kt) of Algeria in 1975 to that in 1980?
Your answer should be very brief. 0.48. What is the ratio of the Emissions(kt) of Austria in 1975 to that in 1980?
Ensure brevity in your answer.  1.04. What is the ratio of the Emissions(kt) in Faeroe Islands in 1975 to that in 1980?
Offer a very short reply. 0.83. What is the ratio of the Emissions(kt) in High income in 1976 to that in 1977?
Keep it short and to the point. 0.98. What is the ratio of the Emissions(kt) of Algeria in 1976 to that in 1977?
Your answer should be compact. 0.94. What is the ratio of the Emissions(kt) in Austria in 1976 to that in 1977?
Give a very brief answer. 1.04. What is the ratio of the Emissions(kt) in Faeroe Islands in 1976 to that in 1977?
Offer a very short reply. 0.81. What is the ratio of the Emissions(kt) in High income in 1976 to that in 1978?
Offer a very short reply. 0.95. What is the ratio of the Emissions(kt) of Algeria in 1976 to that in 1978?
Make the answer very short. 0.63. What is the ratio of the Emissions(kt) of Austria in 1976 to that in 1978?
Your answer should be very brief. 1.02. What is the ratio of the Emissions(kt) of Faeroe Islands in 1976 to that in 1978?
Provide a succinct answer. 0.83. What is the ratio of the Emissions(kt) of High income in 1976 to that in 1979?
Offer a terse response. 0.93. What is the ratio of the Emissions(kt) of Algeria in 1976 to that in 1979?
Your answer should be very brief. 0.86. What is the ratio of the Emissions(kt) of Austria in 1976 to that in 1979?
Your response must be concise. 0.95. What is the ratio of the Emissions(kt) in Faeroe Islands in 1976 to that in 1979?
Offer a very short reply. 0.69. What is the ratio of the Emissions(kt) in High income in 1976 to that in 1980?
Your response must be concise. 0.95. What is the ratio of the Emissions(kt) of Algeria in 1976 to that in 1980?
Provide a short and direct response. 0.59. What is the ratio of the Emissions(kt) in Austria in 1976 to that in 1980?
Keep it short and to the point. 1.12. What is the ratio of the Emissions(kt) in Faeroe Islands in 1976 to that in 1980?
Provide a short and direct response. 0.78. What is the ratio of the Emissions(kt) in High income in 1977 to that in 1978?
Your answer should be compact. 0.97. What is the ratio of the Emissions(kt) in Algeria in 1977 to that in 1978?
Offer a terse response. 0.67. What is the ratio of the Emissions(kt) in Faeroe Islands in 1977 to that in 1978?
Your answer should be very brief. 1.02. What is the ratio of the Emissions(kt) of High income in 1977 to that in 1979?
Provide a short and direct response. 0.95. What is the ratio of the Emissions(kt) in Algeria in 1977 to that in 1979?
Ensure brevity in your answer.  0.92. What is the ratio of the Emissions(kt) of Austria in 1977 to that in 1979?
Your answer should be very brief. 0.91. What is the ratio of the Emissions(kt) of Faeroe Islands in 1977 to that in 1979?
Your response must be concise. 0.85. What is the ratio of the Emissions(kt) in High income in 1977 to that in 1980?
Make the answer very short. 0.97. What is the ratio of the Emissions(kt) of Algeria in 1977 to that in 1980?
Ensure brevity in your answer.  0.63. What is the ratio of the Emissions(kt) of Austria in 1977 to that in 1980?
Ensure brevity in your answer.  1.07. What is the ratio of the Emissions(kt) of Faeroe Islands in 1977 to that in 1980?
Provide a succinct answer. 0.97. What is the ratio of the Emissions(kt) in High income in 1978 to that in 1979?
Your answer should be compact. 0.97. What is the ratio of the Emissions(kt) of Algeria in 1978 to that in 1979?
Your answer should be compact. 1.37. What is the ratio of the Emissions(kt) of Faeroe Islands in 1978 to that in 1979?
Provide a short and direct response. 0.83. What is the ratio of the Emissions(kt) in High income in 1978 to that in 1980?
Offer a very short reply. 0.99. What is the ratio of the Emissions(kt) in Algeria in 1978 to that in 1980?
Your response must be concise. 0.94. What is the ratio of the Emissions(kt) in Austria in 1978 to that in 1980?
Your answer should be compact. 1.1. What is the ratio of the Emissions(kt) of Faeroe Islands in 1978 to that in 1980?
Provide a succinct answer. 0.95. What is the ratio of the Emissions(kt) in High income in 1979 to that in 1980?
Provide a short and direct response. 1.02. What is the ratio of the Emissions(kt) in Algeria in 1979 to that in 1980?
Provide a succinct answer. 0.69. What is the ratio of the Emissions(kt) of Austria in 1979 to that in 1980?
Keep it short and to the point. 1.18. What is the ratio of the Emissions(kt) of Faeroe Islands in 1979 to that in 1980?
Your response must be concise. 1.14. What is the difference between the highest and the second highest Emissions(kt) in High income?
Your answer should be compact. 2.64e+05. What is the difference between the highest and the second highest Emissions(kt) in Algeria?
Offer a terse response. 3989.7. What is the difference between the highest and the second highest Emissions(kt) in Austria?
Provide a succinct answer. 3179.29. What is the difference between the highest and the second highest Emissions(kt) in Faeroe Islands?
Your response must be concise. 58.67. What is the difference between the highest and the lowest Emissions(kt) of High income?
Your response must be concise. 1.62e+06. What is the difference between the highest and the lowest Emissions(kt) in Algeria?
Keep it short and to the point. 3.46e+04. What is the difference between the highest and the lowest Emissions(kt) of Austria?
Your answer should be very brief. 9288.51. What is the difference between the highest and the lowest Emissions(kt) in Faeroe Islands?
Your response must be concise. 179.68. 